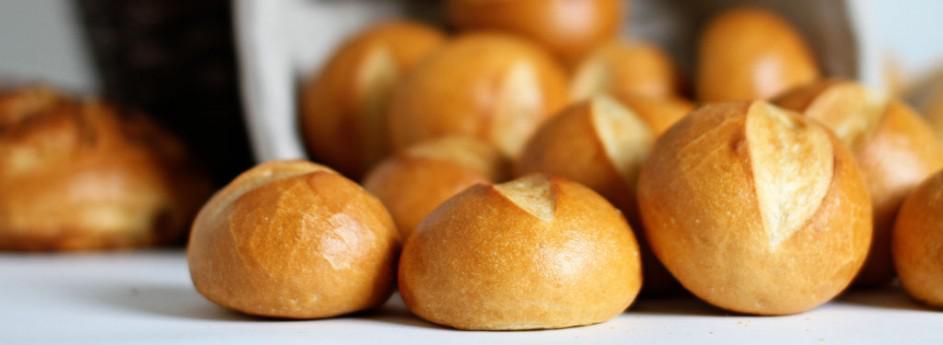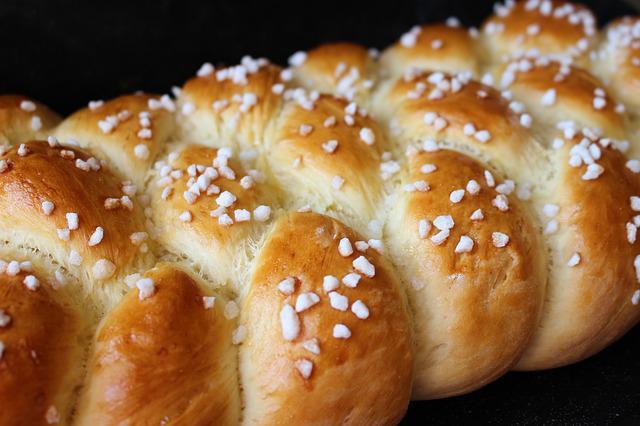The first image is the image on the left, the second image is the image on the right. Evaluate the accuracy of this statement regarding the images: "The left image includes multiple roundish baked loaves with a single slice-mark across the top, and they are not in a container.". Is it true? Answer yes or no. Yes. The first image is the image on the left, the second image is the image on the right. Assess this claim about the two images: "There are at least 4 pieces of bread held in a light colored wicker basket.". Correct or not? Answer yes or no. No. 